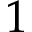<formula> <loc_0><loc_0><loc_500><loc_500>1</formula> 